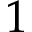<formula> <loc_0><loc_0><loc_500><loc_500>1</formula> 